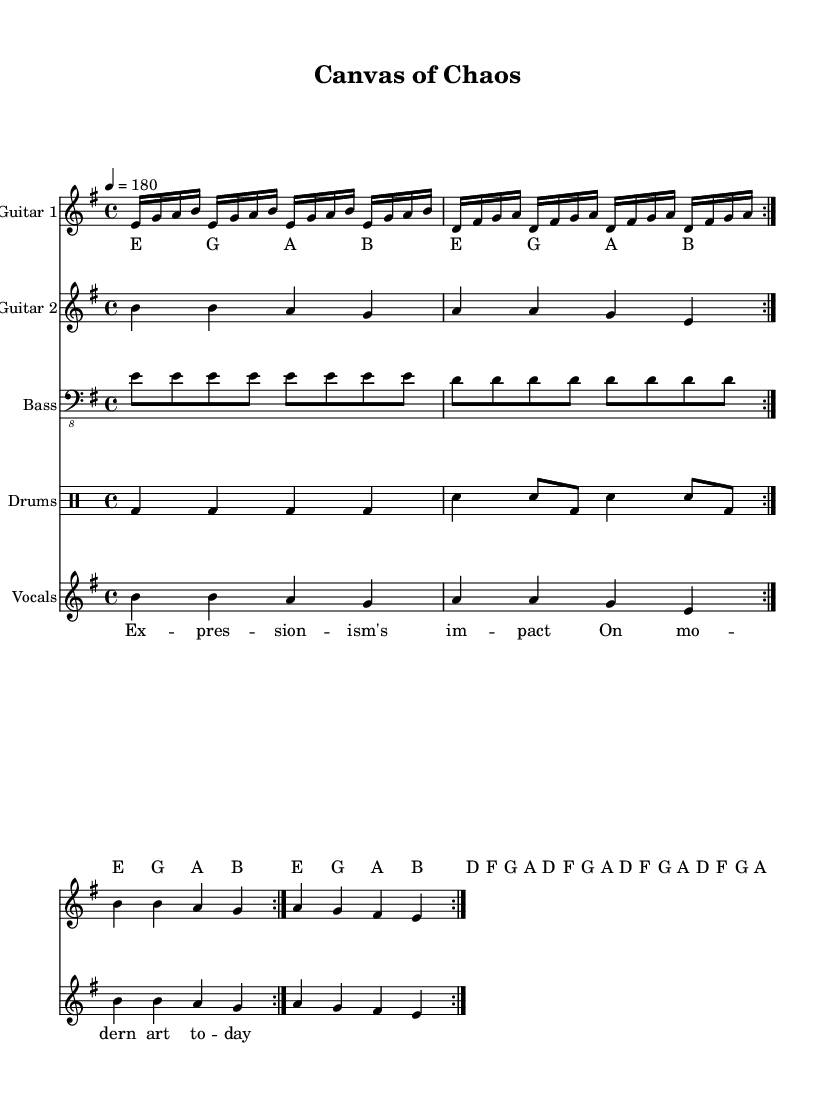What is the key signature of this music? The key signature indicates the key of E minor, which has one sharp (F#). This is confirmed by the presence of F# in the music notes.
Answer: E minor What is the time signature of this music? The time signature is 4/4, which is indicated at the beginning of the sheet music. This means there are four beats in each measure.
Answer: 4/4 What is the tempo marking of this piece? The tempo is marked as quarter note equals 180, which instructs the performer to play at a fast pace. This is also shown at the top of the sheet music.
Answer: 180 How many measures are repeated in this piece? The music has repeats indicated by the "volta" markings. There are two measures that are repeated twice, following the repeat signs within the context of the measures.
Answer: 2 What art movement is referenced in the vocal lyrics? The lyrics mention "Expressionism," which is a prominent art movement known for its focus on depicting emotions. The lyrics explicitly reference the impact of expressionism on modern art.
Answer: Expressionism Which instrument plays the bass line? The bass line is indicated to be played by the instrument labeled "Bass" in the score, shown as a separate staff below the guitars in the layout.
Answer: Bass What rhythmic note value primarily drives the guitar one melody? The guitar one melody largely features sixteenth-note rhythms, which create a fast-paced, aggressive sound typical of thrash metal. This is evident in the notation where e16, g, a, b, appear in rapid succession.
Answer: Sixteenth notes 